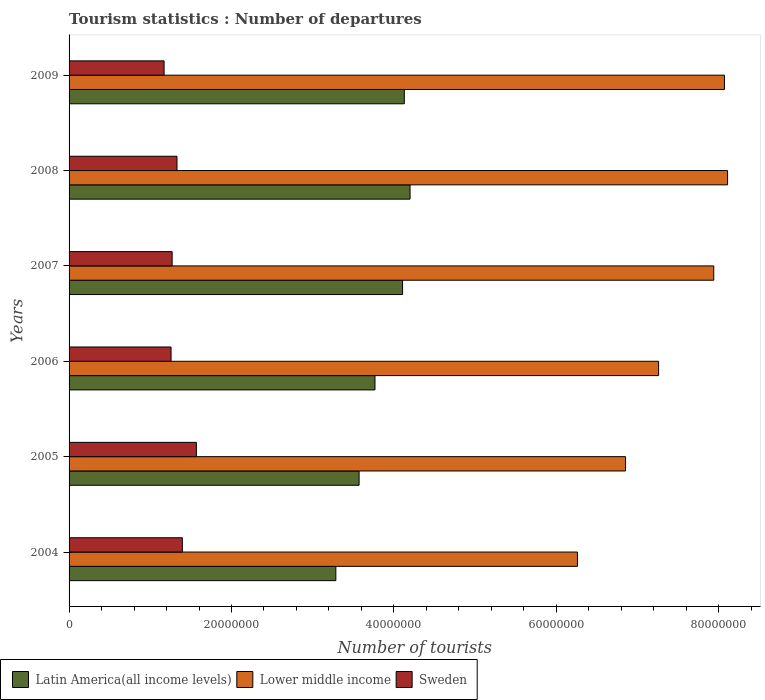How many groups of bars are there?
Make the answer very short. 6. Are the number of bars per tick equal to the number of legend labels?
Make the answer very short. Yes. Are the number of bars on each tick of the Y-axis equal?
Provide a succinct answer. Yes. How many bars are there on the 2nd tick from the top?
Offer a very short reply. 3. How many bars are there on the 2nd tick from the bottom?
Keep it short and to the point. 3. In how many cases, is the number of bars for a given year not equal to the number of legend labels?
Offer a very short reply. 0. What is the number of tourist departures in Lower middle income in 2007?
Keep it short and to the point. 7.94e+07. Across all years, what is the maximum number of tourist departures in Sweden?
Give a very brief answer. 1.57e+07. Across all years, what is the minimum number of tourist departures in Latin America(all income levels)?
Offer a terse response. 3.29e+07. In which year was the number of tourist departures in Sweden maximum?
Your answer should be compact. 2005. What is the total number of tourist departures in Latin America(all income levels) in the graph?
Provide a succinct answer. 2.31e+08. What is the difference between the number of tourist departures in Latin America(all income levels) in 2004 and that in 2009?
Make the answer very short. -8.43e+06. What is the difference between the number of tourist departures in Sweden in 2005 and the number of tourist departures in Lower middle income in 2007?
Keep it short and to the point. -6.37e+07. What is the average number of tourist departures in Latin America(all income levels) per year?
Keep it short and to the point. 3.84e+07. In the year 2005, what is the difference between the number of tourist departures in Latin America(all income levels) and number of tourist departures in Sweden?
Keep it short and to the point. 2.00e+07. What is the ratio of the number of tourist departures in Sweden in 2006 to that in 2007?
Provide a short and direct response. 0.99. What is the difference between the highest and the second highest number of tourist departures in Latin America(all income levels)?
Your answer should be compact. 7.06e+05. What is the difference between the highest and the lowest number of tourist departures in Sweden?
Keep it short and to the point. 3.98e+06. In how many years, is the number of tourist departures in Lower middle income greater than the average number of tourist departures in Lower middle income taken over all years?
Make the answer very short. 3. Is the sum of the number of tourist departures in Lower middle income in 2007 and 2008 greater than the maximum number of tourist departures in Latin America(all income levels) across all years?
Your answer should be compact. Yes. What does the 2nd bar from the bottom in 2004 represents?
Provide a short and direct response. Lower middle income. Is it the case that in every year, the sum of the number of tourist departures in Latin America(all income levels) and number of tourist departures in Sweden is greater than the number of tourist departures in Lower middle income?
Your answer should be very brief. No. Are all the bars in the graph horizontal?
Make the answer very short. Yes. What is the difference between two consecutive major ticks on the X-axis?
Make the answer very short. 2.00e+07. Are the values on the major ticks of X-axis written in scientific E-notation?
Provide a short and direct response. No. Does the graph contain grids?
Give a very brief answer. No. How are the legend labels stacked?
Offer a very short reply. Horizontal. What is the title of the graph?
Offer a very short reply. Tourism statistics : Number of departures. Does "Tuvalu" appear as one of the legend labels in the graph?
Give a very brief answer. No. What is the label or title of the X-axis?
Your answer should be very brief. Number of tourists. What is the label or title of the Y-axis?
Keep it short and to the point. Years. What is the Number of tourists of Latin America(all income levels) in 2004?
Provide a short and direct response. 3.29e+07. What is the Number of tourists of Lower middle income in 2004?
Keep it short and to the point. 6.26e+07. What is the Number of tourists in Sweden in 2004?
Your response must be concise. 1.40e+07. What is the Number of tourists of Latin America(all income levels) in 2005?
Offer a terse response. 3.57e+07. What is the Number of tourists of Lower middle income in 2005?
Give a very brief answer. 6.85e+07. What is the Number of tourists in Sweden in 2005?
Keep it short and to the point. 1.57e+07. What is the Number of tourists of Latin America(all income levels) in 2006?
Offer a terse response. 3.77e+07. What is the Number of tourists of Lower middle income in 2006?
Provide a short and direct response. 7.26e+07. What is the Number of tourists of Sweden in 2006?
Keep it short and to the point. 1.26e+07. What is the Number of tourists of Latin America(all income levels) in 2007?
Your answer should be compact. 4.11e+07. What is the Number of tourists of Lower middle income in 2007?
Make the answer very short. 7.94e+07. What is the Number of tourists in Sweden in 2007?
Keep it short and to the point. 1.27e+07. What is the Number of tourists of Latin America(all income levels) in 2008?
Your answer should be very brief. 4.20e+07. What is the Number of tourists of Lower middle income in 2008?
Offer a terse response. 8.11e+07. What is the Number of tourists of Sweden in 2008?
Your answer should be compact. 1.33e+07. What is the Number of tourists of Latin America(all income levels) in 2009?
Give a very brief answer. 4.13e+07. What is the Number of tourists of Lower middle income in 2009?
Offer a very short reply. 8.07e+07. What is the Number of tourists of Sweden in 2009?
Offer a very short reply. 1.17e+07. Across all years, what is the maximum Number of tourists of Latin America(all income levels)?
Your answer should be very brief. 4.20e+07. Across all years, what is the maximum Number of tourists of Lower middle income?
Keep it short and to the point. 8.11e+07. Across all years, what is the maximum Number of tourists of Sweden?
Ensure brevity in your answer.  1.57e+07. Across all years, what is the minimum Number of tourists in Latin America(all income levels)?
Keep it short and to the point. 3.29e+07. Across all years, what is the minimum Number of tourists in Lower middle income?
Your answer should be very brief. 6.26e+07. Across all years, what is the minimum Number of tourists of Sweden?
Offer a terse response. 1.17e+07. What is the total Number of tourists in Latin America(all income levels) in the graph?
Ensure brevity in your answer.  2.31e+08. What is the total Number of tourists of Lower middle income in the graph?
Make the answer very short. 4.45e+08. What is the total Number of tourists of Sweden in the graph?
Provide a succinct answer. 7.99e+07. What is the difference between the Number of tourists of Latin America(all income levels) in 2004 and that in 2005?
Provide a succinct answer. -2.86e+06. What is the difference between the Number of tourists of Lower middle income in 2004 and that in 2005?
Your answer should be very brief. -5.92e+06. What is the difference between the Number of tourists in Sweden in 2004 and that in 2005?
Make the answer very short. -1.73e+06. What is the difference between the Number of tourists in Latin America(all income levels) in 2004 and that in 2006?
Give a very brief answer. -4.82e+06. What is the difference between the Number of tourists in Lower middle income in 2004 and that in 2006?
Provide a succinct answer. -9.99e+06. What is the difference between the Number of tourists of Sweden in 2004 and that in 2006?
Provide a succinct answer. 1.39e+06. What is the difference between the Number of tourists in Latin America(all income levels) in 2004 and that in 2007?
Keep it short and to the point. -8.22e+06. What is the difference between the Number of tourists in Lower middle income in 2004 and that in 2007?
Offer a terse response. -1.68e+07. What is the difference between the Number of tourists in Sweden in 2004 and that in 2007?
Offer a very short reply. 1.26e+06. What is the difference between the Number of tourists in Latin America(all income levels) in 2004 and that in 2008?
Keep it short and to the point. -9.14e+06. What is the difference between the Number of tourists of Lower middle income in 2004 and that in 2008?
Keep it short and to the point. -1.85e+07. What is the difference between the Number of tourists of Sweden in 2004 and that in 2008?
Make the answer very short. 6.59e+05. What is the difference between the Number of tourists in Latin America(all income levels) in 2004 and that in 2009?
Ensure brevity in your answer.  -8.43e+06. What is the difference between the Number of tourists of Lower middle income in 2004 and that in 2009?
Your response must be concise. -1.81e+07. What is the difference between the Number of tourists in Sweden in 2004 and that in 2009?
Keep it short and to the point. 2.25e+06. What is the difference between the Number of tourists in Latin America(all income levels) in 2005 and that in 2006?
Keep it short and to the point. -1.96e+06. What is the difference between the Number of tourists of Lower middle income in 2005 and that in 2006?
Your answer should be very brief. -4.07e+06. What is the difference between the Number of tourists in Sweden in 2005 and that in 2006?
Give a very brief answer. 3.12e+06. What is the difference between the Number of tourists of Latin America(all income levels) in 2005 and that in 2007?
Give a very brief answer. -5.35e+06. What is the difference between the Number of tourists of Lower middle income in 2005 and that in 2007?
Give a very brief answer. -1.09e+07. What is the difference between the Number of tourists of Sweden in 2005 and that in 2007?
Provide a succinct answer. 2.98e+06. What is the difference between the Number of tourists of Latin America(all income levels) in 2005 and that in 2008?
Give a very brief answer. -6.28e+06. What is the difference between the Number of tourists of Lower middle income in 2005 and that in 2008?
Ensure brevity in your answer.  -1.26e+07. What is the difference between the Number of tourists in Sweden in 2005 and that in 2008?
Give a very brief answer. 2.39e+06. What is the difference between the Number of tourists in Latin America(all income levels) in 2005 and that in 2009?
Offer a terse response. -5.57e+06. What is the difference between the Number of tourists of Lower middle income in 2005 and that in 2009?
Your answer should be very brief. -1.22e+07. What is the difference between the Number of tourists of Sweden in 2005 and that in 2009?
Make the answer very short. 3.98e+06. What is the difference between the Number of tourists of Latin America(all income levels) in 2006 and that in 2007?
Your response must be concise. -3.40e+06. What is the difference between the Number of tourists in Lower middle income in 2006 and that in 2007?
Give a very brief answer. -6.79e+06. What is the difference between the Number of tourists of Sweden in 2006 and that in 2007?
Your answer should be very brief. -1.33e+05. What is the difference between the Number of tourists in Latin America(all income levels) in 2006 and that in 2008?
Offer a very short reply. -4.32e+06. What is the difference between the Number of tourists in Lower middle income in 2006 and that in 2008?
Offer a very short reply. -8.49e+06. What is the difference between the Number of tourists of Sweden in 2006 and that in 2008?
Your response must be concise. -7.32e+05. What is the difference between the Number of tourists in Latin America(all income levels) in 2006 and that in 2009?
Provide a short and direct response. -3.61e+06. What is the difference between the Number of tourists of Lower middle income in 2006 and that in 2009?
Offer a terse response. -8.11e+06. What is the difference between the Number of tourists of Sweden in 2006 and that in 2009?
Provide a short and direct response. 8.60e+05. What is the difference between the Number of tourists of Latin America(all income levels) in 2007 and that in 2008?
Your answer should be very brief. -9.22e+05. What is the difference between the Number of tourists in Lower middle income in 2007 and that in 2008?
Your answer should be compact. -1.70e+06. What is the difference between the Number of tourists of Sweden in 2007 and that in 2008?
Offer a very short reply. -5.99e+05. What is the difference between the Number of tourists in Latin America(all income levels) in 2007 and that in 2009?
Give a very brief answer. -2.15e+05. What is the difference between the Number of tourists of Lower middle income in 2007 and that in 2009?
Make the answer very short. -1.32e+06. What is the difference between the Number of tourists of Sweden in 2007 and that in 2009?
Make the answer very short. 9.93e+05. What is the difference between the Number of tourists in Latin America(all income levels) in 2008 and that in 2009?
Your response must be concise. 7.06e+05. What is the difference between the Number of tourists in Lower middle income in 2008 and that in 2009?
Offer a very short reply. 3.82e+05. What is the difference between the Number of tourists in Sweden in 2008 and that in 2009?
Offer a very short reply. 1.59e+06. What is the difference between the Number of tourists in Latin America(all income levels) in 2004 and the Number of tourists in Lower middle income in 2005?
Provide a succinct answer. -3.57e+07. What is the difference between the Number of tourists of Latin America(all income levels) in 2004 and the Number of tourists of Sweden in 2005?
Your answer should be compact. 1.72e+07. What is the difference between the Number of tourists of Lower middle income in 2004 and the Number of tourists of Sweden in 2005?
Your response must be concise. 4.69e+07. What is the difference between the Number of tourists of Latin America(all income levels) in 2004 and the Number of tourists of Lower middle income in 2006?
Your answer should be very brief. -3.97e+07. What is the difference between the Number of tourists in Latin America(all income levels) in 2004 and the Number of tourists in Sweden in 2006?
Make the answer very short. 2.03e+07. What is the difference between the Number of tourists in Lower middle income in 2004 and the Number of tourists in Sweden in 2006?
Ensure brevity in your answer.  5.00e+07. What is the difference between the Number of tourists in Latin America(all income levels) in 2004 and the Number of tourists in Lower middle income in 2007?
Your answer should be compact. -4.65e+07. What is the difference between the Number of tourists of Latin America(all income levels) in 2004 and the Number of tourists of Sweden in 2007?
Give a very brief answer. 2.02e+07. What is the difference between the Number of tourists in Lower middle income in 2004 and the Number of tourists in Sweden in 2007?
Give a very brief answer. 4.99e+07. What is the difference between the Number of tourists in Latin America(all income levels) in 2004 and the Number of tourists in Lower middle income in 2008?
Provide a short and direct response. -4.82e+07. What is the difference between the Number of tourists of Latin America(all income levels) in 2004 and the Number of tourists of Sweden in 2008?
Offer a terse response. 1.96e+07. What is the difference between the Number of tourists of Lower middle income in 2004 and the Number of tourists of Sweden in 2008?
Give a very brief answer. 4.93e+07. What is the difference between the Number of tourists in Latin America(all income levels) in 2004 and the Number of tourists in Lower middle income in 2009?
Offer a very short reply. -4.79e+07. What is the difference between the Number of tourists of Latin America(all income levels) in 2004 and the Number of tourists of Sweden in 2009?
Provide a succinct answer. 2.12e+07. What is the difference between the Number of tourists of Lower middle income in 2004 and the Number of tourists of Sweden in 2009?
Offer a very short reply. 5.09e+07. What is the difference between the Number of tourists of Latin America(all income levels) in 2005 and the Number of tourists of Lower middle income in 2006?
Ensure brevity in your answer.  -3.69e+07. What is the difference between the Number of tourists of Latin America(all income levels) in 2005 and the Number of tourists of Sweden in 2006?
Your answer should be very brief. 2.32e+07. What is the difference between the Number of tourists in Lower middle income in 2005 and the Number of tourists in Sweden in 2006?
Offer a very short reply. 5.60e+07. What is the difference between the Number of tourists of Latin America(all income levels) in 2005 and the Number of tourists of Lower middle income in 2007?
Your answer should be compact. -4.37e+07. What is the difference between the Number of tourists in Latin America(all income levels) in 2005 and the Number of tourists in Sweden in 2007?
Your response must be concise. 2.30e+07. What is the difference between the Number of tourists in Lower middle income in 2005 and the Number of tourists in Sweden in 2007?
Your response must be concise. 5.58e+07. What is the difference between the Number of tourists of Latin America(all income levels) in 2005 and the Number of tourists of Lower middle income in 2008?
Keep it short and to the point. -4.54e+07. What is the difference between the Number of tourists in Latin America(all income levels) in 2005 and the Number of tourists in Sweden in 2008?
Provide a short and direct response. 2.24e+07. What is the difference between the Number of tourists in Lower middle income in 2005 and the Number of tourists in Sweden in 2008?
Offer a terse response. 5.52e+07. What is the difference between the Number of tourists of Latin America(all income levels) in 2005 and the Number of tourists of Lower middle income in 2009?
Provide a succinct answer. -4.50e+07. What is the difference between the Number of tourists of Latin America(all income levels) in 2005 and the Number of tourists of Sweden in 2009?
Your response must be concise. 2.40e+07. What is the difference between the Number of tourists of Lower middle income in 2005 and the Number of tourists of Sweden in 2009?
Your response must be concise. 5.68e+07. What is the difference between the Number of tourists in Latin America(all income levels) in 2006 and the Number of tourists in Lower middle income in 2007?
Provide a succinct answer. -4.17e+07. What is the difference between the Number of tourists of Latin America(all income levels) in 2006 and the Number of tourists of Sweden in 2007?
Give a very brief answer. 2.50e+07. What is the difference between the Number of tourists in Lower middle income in 2006 and the Number of tourists in Sweden in 2007?
Ensure brevity in your answer.  5.99e+07. What is the difference between the Number of tourists of Latin America(all income levels) in 2006 and the Number of tourists of Lower middle income in 2008?
Offer a very short reply. -4.34e+07. What is the difference between the Number of tourists of Latin America(all income levels) in 2006 and the Number of tourists of Sweden in 2008?
Give a very brief answer. 2.44e+07. What is the difference between the Number of tourists of Lower middle income in 2006 and the Number of tourists of Sweden in 2008?
Provide a short and direct response. 5.93e+07. What is the difference between the Number of tourists in Latin America(all income levels) in 2006 and the Number of tourists in Lower middle income in 2009?
Offer a terse response. -4.30e+07. What is the difference between the Number of tourists in Latin America(all income levels) in 2006 and the Number of tourists in Sweden in 2009?
Make the answer very short. 2.60e+07. What is the difference between the Number of tourists in Lower middle income in 2006 and the Number of tourists in Sweden in 2009?
Your response must be concise. 6.09e+07. What is the difference between the Number of tourists in Latin America(all income levels) in 2007 and the Number of tourists in Lower middle income in 2008?
Your response must be concise. -4.00e+07. What is the difference between the Number of tourists in Latin America(all income levels) in 2007 and the Number of tourists in Sweden in 2008?
Offer a very short reply. 2.78e+07. What is the difference between the Number of tourists in Lower middle income in 2007 and the Number of tourists in Sweden in 2008?
Offer a very short reply. 6.61e+07. What is the difference between the Number of tourists of Latin America(all income levels) in 2007 and the Number of tourists of Lower middle income in 2009?
Ensure brevity in your answer.  -3.96e+07. What is the difference between the Number of tourists of Latin America(all income levels) in 2007 and the Number of tourists of Sweden in 2009?
Make the answer very short. 2.94e+07. What is the difference between the Number of tourists of Lower middle income in 2007 and the Number of tourists of Sweden in 2009?
Offer a very short reply. 6.77e+07. What is the difference between the Number of tourists of Latin America(all income levels) in 2008 and the Number of tourists of Lower middle income in 2009?
Give a very brief answer. -3.87e+07. What is the difference between the Number of tourists of Latin America(all income levels) in 2008 and the Number of tourists of Sweden in 2009?
Keep it short and to the point. 3.03e+07. What is the difference between the Number of tourists in Lower middle income in 2008 and the Number of tourists in Sweden in 2009?
Offer a very short reply. 6.94e+07. What is the average Number of tourists of Latin America(all income levels) per year?
Your response must be concise. 3.84e+07. What is the average Number of tourists in Lower middle income per year?
Offer a very short reply. 7.42e+07. What is the average Number of tourists of Sweden per year?
Provide a short and direct response. 1.33e+07. In the year 2004, what is the difference between the Number of tourists of Latin America(all income levels) and Number of tourists of Lower middle income?
Your answer should be compact. -2.98e+07. In the year 2004, what is the difference between the Number of tourists of Latin America(all income levels) and Number of tourists of Sweden?
Ensure brevity in your answer.  1.89e+07. In the year 2004, what is the difference between the Number of tourists of Lower middle income and Number of tourists of Sweden?
Offer a terse response. 4.87e+07. In the year 2005, what is the difference between the Number of tourists in Latin America(all income levels) and Number of tourists in Lower middle income?
Give a very brief answer. -3.28e+07. In the year 2005, what is the difference between the Number of tourists of Latin America(all income levels) and Number of tourists of Sweden?
Offer a terse response. 2.00e+07. In the year 2005, what is the difference between the Number of tourists of Lower middle income and Number of tourists of Sweden?
Offer a very short reply. 5.29e+07. In the year 2006, what is the difference between the Number of tourists in Latin America(all income levels) and Number of tourists in Lower middle income?
Provide a short and direct response. -3.49e+07. In the year 2006, what is the difference between the Number of tourists in Latin America(all income levels) and Number of tourists in Sweden?
Offer a terse response. 2.51e+07. In the year 2006, what is the difference between the Number of tourists in Lower middle income and Number of tourists in Sweden?
Your answer should be compact. 6.00e+07. In the year 2007, what is the difference between the Number of tourists of Latin America(all income levels) and Number of tourists of Lower middle income?
Give a very brief answer. -3.83e+07. In the year 2007, what is the difference between the Number of tourists of Latin America(all income levels) and Number of tourists of Sweden?
Provide a short and direct response. 2.84e+07. In the year 2007, what is the difference between the Number of tourists in Lower middle income and Number of tourists in Sweden?
Give a very brief answer. 6.67e+07. In the year 2008, what is the difference between the Number of tourists in Latin America(all income levels) and Number of tourists in Lower middle income?
Offer a very short reply. -3.91e+07. In the year 2008, what is the difference between the Number of tourists of Latin America(all income levels) and Number of tourists of Sweden?
Ensure brevity in your answer.  2.87e+07. In the year 2008, what is the difference between the Number of tourists of Lower middle income and Number of tourists of Sweden?
Your answer should be compact. 6.78e+07. In the year 2009, what is the difference between the Number of tourists of Latin America(all income levels) and Number of tourists of Lower middle income?
Give a very brief answer. -3.94e+07. In the year 2009, what is the difference between the Number of tourists in Latin America(all income levels) and Number of tourists in Sweden?
Offer a terse response. 2.96e+07. In the year 2009, what is the difference between the Number of tourists in Lower middle income and Number of tourists in Sweden?
Ensure brevity in your answer.  6.90e+07. What is the ratio of the Number of tourists in Latin America(all income levels) in 2004 to that in 2005?
Provide a short and direct response. 0.92. What is the ratio of the Number of tourists in Lower middle income in 2004 to that in 2005?
Your answer should be compact. 0.91. What is the ratio of the Number of tourists of Sweden in 2004 to that in 2005?
Give a very brief answer. 0.89. What is the ratio of the Number of tourists in Latin America(all income levels) in 2004 to that in 2006?
Give a very brief answer. 0.87. What is the ratio of the Number of tourists of Lower middle income in 2004 to that in 2006?
Provide a short and direct response. 0.86. What is the ratio of the Number of tourists in Sweden in 2004 to that in 2006?
Make the answer very short. 1.11. What is the ratio of the Number of tourists of Latin America(all income levels) in 2004 to that in 2007?
Give a very brief answer. 0.8. What is the ratio of the Number of tourists of Lower middle income in 2004 to that in 2007?
Give a very brief answer. 0.79. What is the ratio of the Number of tourists of Sweden in 2004 to that in 2007?
Offer a terse response. 1.1. What is the ratio of the Number of tourists in Latin America(all income levels) in 2004 to that in 2008?
Your answer should be compact. 0.78. What is the ratio of the Number of tourists of Lower middle income in 2004 to that in 2008?
Provide a succinct answer. 0.77. What is the ratio of the Number of tourists of Sweden in 2004 to that in 2008?
Ensure brevity in your answer.  1.05. What is the ratio of the Number of tourists of Latin America(all income levels) in 2004 to that in 2009?
Give a very brief answer. 0.8. What is the ratio of the Number of tourists of Lower middle income in 2004 to that in 2009?
Ensure brevity in your answer.  0.78. What is the ratio of the Number of tourists in Sweden in 2004 to that in 2009?
Provide a succinct answer. 1.19. What is the ratio of the Number of tourists in Latin America(all income levels) in 2005 to that in 2006?
Provide a succinct answer. 0.95. What is the ratio of the Number of tourists in Lower middle income in 2005 to that in 2006?
Provide a short and direct response. 0.94. What is the ratio of the Number of tourists of Sweden in 2005 to that in 2006?
Provide a succinct answer. 1.25. What is the ratio of the Number of tourists in Latin America(all income levels) in 2005 to that in 2007?
Your response must be concise. 0.87. What is the ratio of the Number of tourists in Lower middle income in 2005 to that in 2007?
Give a very brief answer. 0.86. What is the ratio of the Number of tourists in Sweden in 2005 to that in 2007?
Keep it short and to the point. 1.24. What is the ratio of the Number of tourists of Latin America(all income levels) in 2005 to that in 2008?
Your response must be concise. 0.85. What is the ratio of the Number of tourists in Lower middle income in 2005 to that in 2008?
Offer a very short reply. 0.85. What is the ratio of the Number of tourists of Sweden in 2005 to that in 2008?
Keep it short and to the point. 1.18. What is the ratio of the Number of tourists of Latin America(all income levels) in 2005 to that in 2009?
Your answer should be very brief. 0.87. What is the ratio of the Number of tourists in Lower middle income in 2005 to that in 2009?
Your response must be concise. 0.85. What is the ratio of the Number of tourists in Sweden in 2005 to that in 2009?
Keep it short and to the point. 1.34. What is the ratio of the Number of tourists in Latin America(all income levels) in 2006 to that in 2007?
Provide a short and direct response. 0.92. What is the ratio of the Number of tourists of Lower middle income in 2006 to that in 2007?
Your answer should be compact. 0.91. What is the ratio of the Number of tourists of Sweden in 2006 to that in 2007?
Ensure brevity in your answer.  0.99. What is the ratio of the Number of tourists in Latin America(all income levels) in 2006 to that in 2008?
Offer a terse response. 0.9. What is the ratio of the Number of tourists in Lower middle income in 2006 to that in 2008?
Your answer should be very brief. 0.9. What is the ratio of the Number of tourists of Sweden in 2006 to that in 2008?
Provide a short and direct response. 0.94. What is the ratio of the Number of tourists in Latin America(all income levels) in 2006 to that in 2009?
Your answer should be compact. 0.91. What is the ratio of the Number of tourists of Lower middle income in 2006 to that in 2009?
Provide a succinct answer. 0.9. What is the ratio of the Number of tourists in Sweden in 2006 to that in 2009?
Offer a very short reply. 1.07. What is the ratio of the Number of tourists of Latin America(all income levels) in 2007 to that in 2008?
Your response must be concise. 0.98. What is the ratio of the Number of tourists in Lower middle income in 2007 to that in 2008?
Make the answer very short. 0.98. What is the ratio of the Number of tourists of Sweden in 2007 to that in 2008?
Provide a short and direct response. 0.95. What is the ratio of the Number of tourists in Latin America(all income levels) in 2007 to that in 2009?
Keep it short and to the point. 0.99. What is the ratio of the Number of tourists in Lower middle income in 2007 to that in 2009?
Ensure brevity in your answer.  0.98. What is the ratio of the Number of tourists of Sweden in 2007 to that in 2009?
Provide a short and direct response. 1.08. What is the ratio of the Number of tourists of Latin America(all income levels) in 2008 to that in 2009?
Provide a succinct answer. 1.02. What is the ratio of the Number of tourists in Lower middle income in 2008 to that in 2009?
Ensure brevity in your answer.  1. What is the ratio of the Number of tourists of Sweden in 2008 to that in 2009?
Give a very brief answer. 1.14. What is the difference between the highest and the second highest Number of tourists of Latin America(all income levels)?
Offer a very short reply. 7.06e+05. What is the difference between the highest and the second highest Number of tourists in Lower middle income?
Offer a very short reply. 3.82e+05. What is the difference between the highest and the second highest Number of tourists in Sweden?
Offer a terse response. 1.73e+06. What is the difference between the highest and the lowest Number of tourists of Latin America(all income levels)?
Provide a short and direct response. 9.14e+06. What is the difference between the highest and the lowest Number of tourists of Lower middle income?
Your answer should be compact. 1.85e+07. What is the difference between the highest and the lowest Number of tourists of Sweden?
Give a very brief answer. 3.98e+06. 